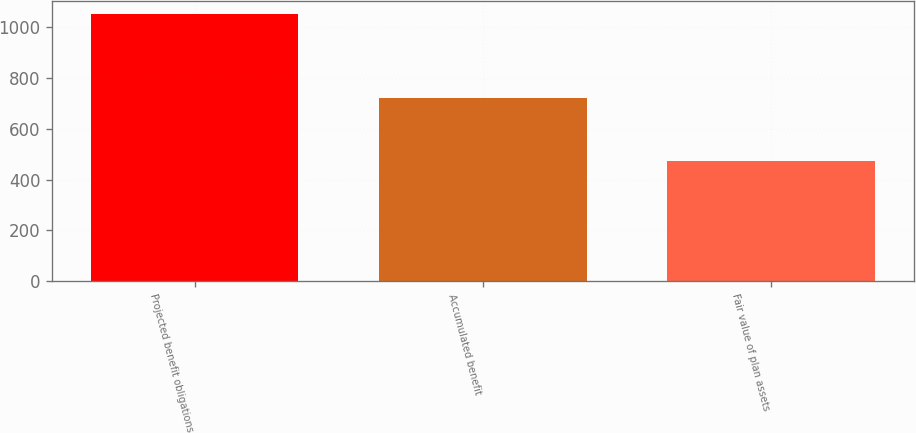<chart> <loc_0><loc_0><loc_500><loc_500><bar_chart><fcel>Projected benefit obligations<fcel>Accumulated benefit<fcel>Fair value of plan assets<nl><fcel>1051<fcel>721<fcel>473<nl></chart> 